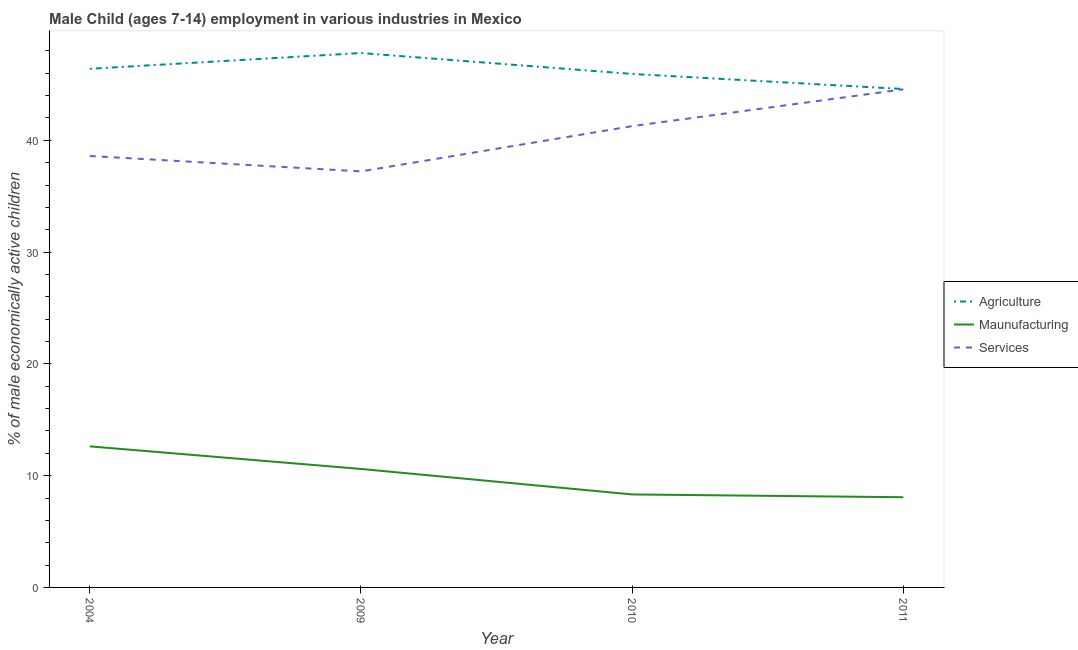How many different coloured lines are there?
Your answer should be compact. 3. What is the percentage of economically active children in services in 2011?
Give a very brief answer. 44.56. Across all years, what is the maximum percentage of economically active children in agriculture?
Your answer should be very brief. 47.81. Across all years, what is the minimum percentage of economically active children in services?
Your answer should be compact. 37.22. What is the total percentage of economically active children in manufacturing in the graph?
Offer a very short reply. 39.61. What is the difference between the percentage of economically active children in manufacturing in 2004 and that in 2011?
Your response must be concise. 4.55. What is the difference between the percentage of economically active children in services in 2010 and the percentage of economically active children in agriculture in 2011?
Ensure brevity in your answer.  -3.32. What is the average percentage of economically active children in agriculture per year?
Your response must be concise. 46.19. In the year 2004, what is the difference between the percentage of economically active children in agriculture and percentage of economically active children in manufacturing?
Offer a terse response. 33.78. In how many years, is the percentage of economically active children in services greater than 18 %?
Keep it short and to the point. 4. What is the ratio of the percentage of economically active children in manufacturing in 2004 to that in 2011?
Provide a short and direct response. 1.56. Is the difference between the percentage of economically active children in agriculture in 2004 and 2009 greater than the difference between the percentage of economically active children in manufacturing in 2004 and 2009?
Your response must be concise. No. What is the difference between the highest and the second highest percentage of economically active children in services?
Your answer should be compact. 3.29. What is the difference between the highest and the lowest percentage of economically active children in manufacturing?
Keep it short and to the point. 4.55. Is it the case that in every year, the sum of the percentage of economically active children in agriculture and percentage of economically active children in manufacturing is greater than the percentage of economically active children in services?
Give a very brief answer. Yes. Is the percentage of economically active children in agriculture strictly greater than the percentage of economically active children in services over the years?
Your response must be concise. Yes. How many lines are there?
Your response must be concise. 3. How many years are there in the graph?
Your response must be concise. 4. Are the values on the major ticks of Y-axis written in scientific E-notation?
Provide a short and direct response. No. Does the graph contain any zero values?
Provide a succinct answer. No. How many legend labels are there?
Make the answer very short. 3. How are the legend labels stacked?
Provide a short and direct response. Vertical. What is the title of the graph?
Ensure brevity in your answer.  Male Child (ages 7-14) employment in various industries in Mexico. Does "Interest" appear as one of the legend labels in the graph?
Give a very brief answer. No. What is the label or title of the X-axis?
Your response must be concise. Year. What is the label or title of the Y-axis?
Make the answer very short. % of male economically active children. What is the % of male economically active children in Agriculture in 2004?
Your response must be concise. 46.4. What is the % of male economically active children in Maunufacturing in 2004?
Make the answer very short. 12.62. What is the % of male economically active children of Services in 2004?
Make the answer very short. 38.6. What is the % of male economically active children in Agriculture in 2009?
Keep it short and to the point. 47.81. What is the % of male economically active children of Services in 2009?
Make the answer very short. 37.22. What is the % of male economically active children of Agriculture in 2010?
Your response must be concise. 45.94. What is the % of male economically active children in Maunufacturing in 2010?
Keep it short and to the point. 8.32. What is the % of male economically active children of Services in 2010?
Provide a short and direct response. 41.27. What is the % of male economically active children of Agriculture in 2011?
Ensure brevity in your answer.  44.59. What is the % of male economically active children of Maunufacturing in 2011?
Give a very brief answer. 8.07. What is the % of male economically active children of Services in 2011?
Your answer should be compact. 44.56. Across all years, what is the maximum % of male economically active children of Agriculture?
Your response must be concise. 47.81. Across all years, what is the maximum % of male economically active children in Maunufacturing?
Keep it short and to the point. 12.62. Across all years, what is the maximum % of male economically active children of Services?
Keep it short and to the point. 44.56. Across all years, what is the minimum % of male economically active children of Agriculture?
Make the answer very short. 44.59. Across all years, what is the minimum % of male economically active children in Maunufacturing?
Offer a terse response. 8.07. Across all years, what is the minimum % of male economically active children of Services?
Offer a terse response. 37.22. What is the total % of male economically active children in Agriculture in the graph?
Keep it short and to the point. 184.74. What is the total % of male economically active children of Maunufacturing in the graph?
Give a very brief answer. 39.61. What is the total % of male economically active children of Services in the graph?
Make the answer very short. 161.65. What is the difference between the % of male economically active children in Agriculture in 2004 and that in 2009?
Make the answer very short. -1.41. What is the difference between the % of male economically active children in Maunufacturing in 2004 and that in 2009?
Provide a succinct answer. 2.02. What is the difference between the % of male economically active children in Services in 2004 and that in 2009?
Provide a succinct answer. 1.38. What is the difference between the % of male economically active children in Agriculture in 2004 and that in 2010?
Provide a short and direct response. 0.46. What is the difference between the % of male economically active children in Maunufacturing in 2004 and that in 2010?
Offer a terse response. 4.3. What is the difference between the % of male economically active children of Services in 2004 and that in 2010?
Your response must be concise. -2.67. What is the difference between the % of male economically active children in Agriculture in 2004 and that in 2011?
Your answer should be very brief. 1.81. What is the difference between the % of male economically active children of Maunufacturing in 2004 and that in 2011?
Your answer should be very brief. 4.55. What is the difference between the % of male economically active children of Services in 2004 and that in 2011?
Your response must be concise. -5.96. What is the difference between the % of male economically active children of Agriculture in 2009 and that in 2010?
Provide a short and direct response. 1.87. What is the difference between the % of male economically active children of Maunufacturing in 2009 and that in 2010?
Your response must be concise. 2.28. What is the difference between the % of male economically active children in Services in 2009 and that in 2010?
Ensure brevity in your answer.  -4.05. What is the difference between the % of male economically active children of Agriculture in 2009 and that in 2011?
Provide a succinct answer. 3.22. What is the difference between the % of male economically active children in Maunufacturing in 2009 and that in 2011?
Give a very brief answer. 2.53. What is the difference between the % of male economically active children of Services in 2009 and that in 2011?
Your response must be concise. -7.34. What is the difference between the % of male economically active children in Agriculture in 2010 and that in 2011?
Give a very brief answer. 1.35. What is the difference between the % of male economically active children in Services in 2010 and that in 2011?
Ensure brevity in your answer.  -3.29. What is the difference between the % of male economically active children in Agriculture in 2004 and the % of male economically active children in Maunufacturing in 2009?
Give a very brief answer. 35.8. What is the difference between the % of male economically active children of Agriculture in 2004 and the % of male economically active children of Services in 2009?
Ensure brevity in your answer.  9.18. What is the difference between the % of male economically active children of Maunufacturing in 2004 and the % of male economically active children of Services in 2009?
Your answer should be compact. -24.6. What is the difference between the % of male economically active children in Agriculture in 2004 and the % of male economically active children in Maunufacturing in 2010?
Give a very brief answer. 38.08. What is the difference between the % of male economically active children in Agriculture in 2004 and the % of male economically active children in Services in 2010?
Keep it short and to the point. 5.13. What is the difference between the % of male economically active children of Maunufacturing in 2004 and the % of male economically active children of Services in 2010?
Provide a succinct answer. -28.65. What is the difference between the % of male economically active children of Agriculture in 2004 and the % of male economically active children of Maunufacturing in 2011?
Make the answer very short. 38.33. What is the difference between the % of male economically active children of Agriculture in 2004 and the % of male economically active children of Services in 2011?
Give a very brief answer. 1.84. What is the difference between the % of male economically active children in Maunufacturing in 2004 and the % of male economically active children in Services in 2011?
Provide a succinct answer. -31.94. What is the difference between the % of male economically active children of Agriculture in 2009 and the % of male economically active children of Maunufacturing in 2010?
Provide a short and direct response. 39.49. What is the difference between the % of male economically active children in Agriculture in 2009 and the % of male economically active children in Services in 2010?
Provide a succinct answer. 6.54. What is the difference between the % of male economically active children in Maunufacturing in 2009 and the % of male economically active children in Services in 2010?
Offer a very short reply. -30.67. What is the difference between the % of male economically active children in Agriculture in 2009 and the % of male economically active children in Maunufacturing in 2011?
Give a very brief answer. 39.74. What is the difference between the % of male economically active children of Maunufacturing in 2009 and the % of male economically active children of Services in 2011?
Give a very brief answer. -33.96. What is the difference between the % of male economically active children in Agriculture in 2010 and the % of male economically active children in Maunufacturing in 2011?
Provide a short and direct response. 37.87. What is the difference between the % of male economically active children of Agriculture in 2010 and the % of male economically active children of Services in 2011?
Keep it short and to the point. 1.38. What is the difference between the % of male economically active children of Maunufacturing in 2010 and the % of male economically active children of Services in 2011?
Provide a succinct answer. -36.24. What is the average % of male economically active children in Agriculture per year?
Make the answer very short. 46.19. What is the average % of male economically active children of Maunufacturing per year?
Give a very brief answer. 9.9. What is the average % of male economically active children in Services per year?
Your answer should be very brief. 40.41. In the year 2004, what is the difference between the % of male economically active children of Agriculture and % of male economically active children of Maunufacturing?
Provide a succinct answer. 33.78. In the year 2004, what is the difference between the % of male economically active children of Maunufacturing and % of male economically active children of Services?
Give a very brief answer. -25.98. In the year 2009, what is the difference between the % of male economically active children in Agriculture and % of male economically active children in Maunufacturing?
Your answer should be compact. 37.21. In the year 2009, what is the difference between the % of male economically active children in Agriculture and % of male economically active children in Services?
Your answer should be very brief. 10.59. In the year 2009, what is the difference between the % of male economically active children in Maunufacturing and % of male economically active children in Services?
Ensure brevity in your answer.  -26.62. In the year 2010, what is the difference between the % of male economically active children of Agriculture and % of male economically active children of Maunufacturing?
Your answer should be very brief. 37.62. In the year 2010, what is the difference between the % of male economically active children of Agriculture and % of male economically active children of Services?
Give a very brief answer. 4.67. In the year 2010, what is the difference between the % of male economically active children of Maunufacturing and % of male economically active children of Services?
Give a very brief answer. -32.95. In the year 2011, what is the difference between the % of male economically active children of Agriculture and % of male economically active children of Maunufacturing?
Offer a terse response. 36.52. In the year 2011, what is the difference between the % of male economically active children in Agriculture and % of male economically active children in Services?
Your response must be concise. 0.03. In the year 2011, what is the difference between the % of male economically active children of Maunufacturing and % of male economically active children of Services?
Make the answer very short. -36.49. What is the ratio of the % of male economically active children in Agriculture in 2004 to that in 2009?
Provide a succinct answer. 0.97. What is the ratio of the % of male economically active children of Maunufacturing in 2004 to that in 2009?
Your answer should be very brief. 1.19. What is the ratio of the % of male economically active children of Services in 2004 to that in 2009?
Provide a succinct answer. 1.04. What is the ratio of the % of male economically active children in Maunufacturing in 2004 to that in 2010?
Make the answer very short. 1.52. What is the ratio of the % of male economically active children of Services in 2004 to that in 2010?
Your answer should be very brief. 0.94. What is the ratio of the % of male economically active children of Agriculture in 2004 to that in 2011?
Make the answer very short. 1.04. What is the ratio of the % of male economically active children of Maunufacturing in 2004 to that in 2011?
Your answer should be compact. 1.56. What is the ratio of the % of male economically active children in Services in 2004 to that in 2011?
Provide a short and direct response. 0.87. What is the ratio of the % of male economically active children of Agriculture in 2009 to that in 2010?
Give a very brief answer. 1.04. What is the ratio of the % of male economically active children in Maunufacturing in 2009 to that in 2010?
Your response must be concise. 1.27. What is the ratio of the % of male economically active children in Services in 2009 to that in 2010?
Give a very brief answer. 0.9. What is the ratio of the % of male economically active children in Agriculture in 2009 to that in 2011?
Your response must be concise. 1.07. What is the ratio of the % of male economically active children of Maunufacturing in 2009 to that in 2011?
Your answer should be very brief. 1.31. What is the ratio of the % of male economically active children in Services in 2009 to that in 2011?
Offer a terse response. 0.84. What is the ratio of the % of male economically active children of Agriculture in 2010 to that in 2011?
Offer a terse response. 1.03. What is the ratio of the % of male economically active children of Maunufacturing in 2010 to that in 2011?
Your answer should be very brief. 1.03. What is the ratio of the % of male economically active children of Services in 2010 to that in 2011?
Give a very brief answer. 0.93. What is the difference between the highest and the second highest % of male economically active children of Agriculture?
Keep it short and to the point. 1.41. What is the difference between the highest and the second highest % of male economically active children of Maunufacturing?
Offer a terse response. 2.02. What is the difference between the highest and the second highest % of male economically active children of Services?
Provide a succinct answer. 3.29. What is the difference between the highest and the lowest % of male economically active children of Agriculture?
Your answer should be very brief. 3.22. What is the difference between the highest and the lowest % of male economically active children in Maunufacturing?
Offer a very short reply. 4.55. What is the difference between the highest and the lowest % of male economically active children of Services?
Your answer should be compact. 7.34. 